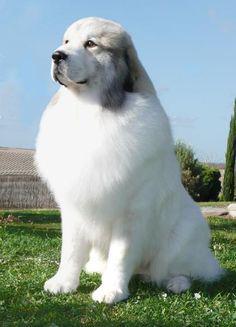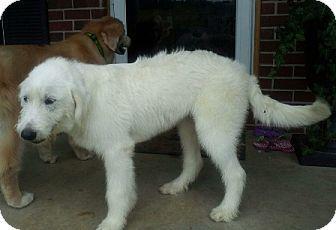The first image is the image on the left, the second image is the image on the right. For the images shown, is this caption "All of the white dogs are facing leftward, and one dog is posed on green grass." true? Answer yes or no. Yes. The first image is the image on the left, the second image is the image on the right. Analyze the images presented: Is the assertion "In one image a dog is sitting down and in the other image the dog is standing." valid? Answer yes or no. Yes. 